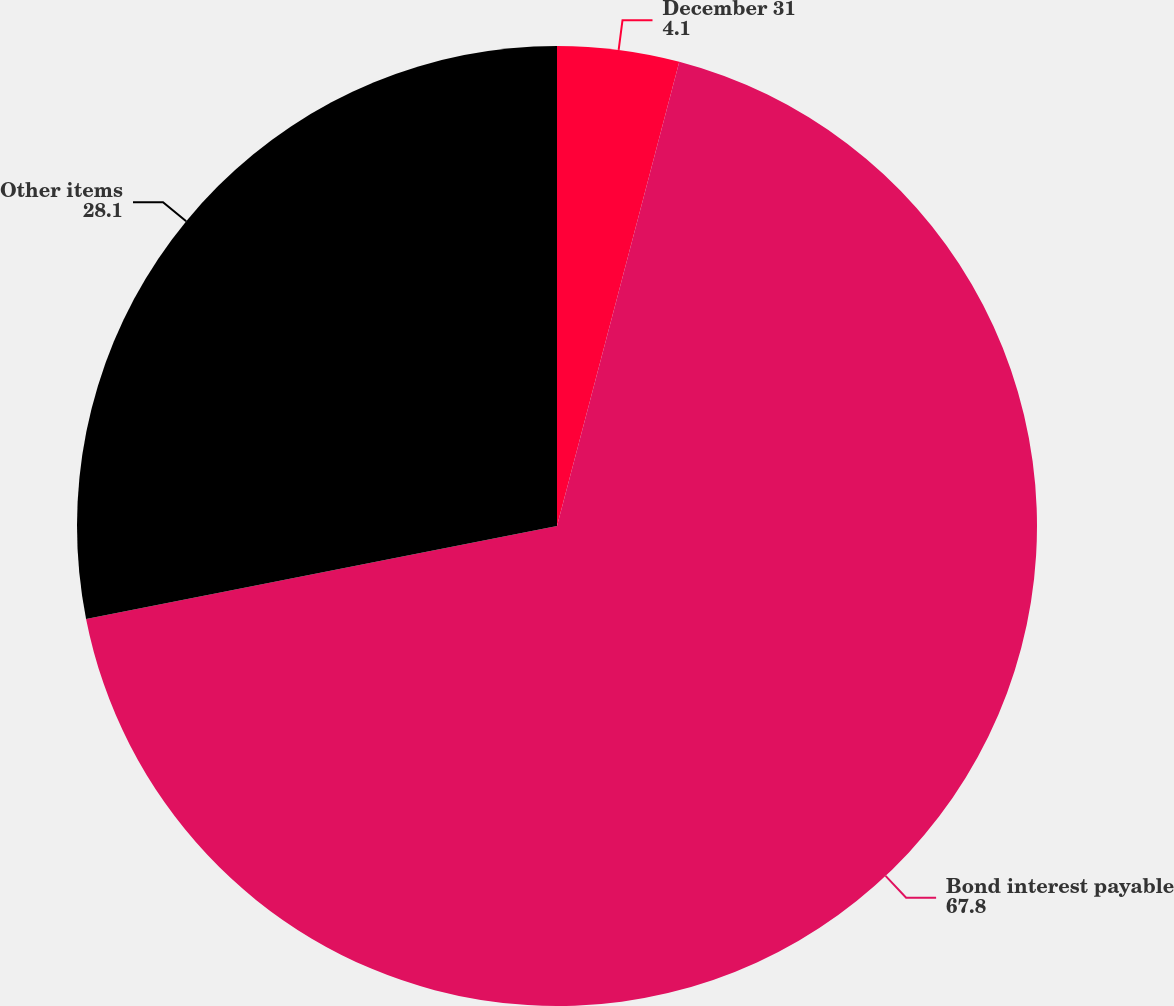Convert chart to OTSL. <chart><loc_0><loc_0><loc_500><loc_500><pie_chart><fcel>December 31<fcel>Bond interest payable<fcel>Other items<nl><fcel>4.1%<fcel>67.8%<fcel>28.1%<nl></chart> 